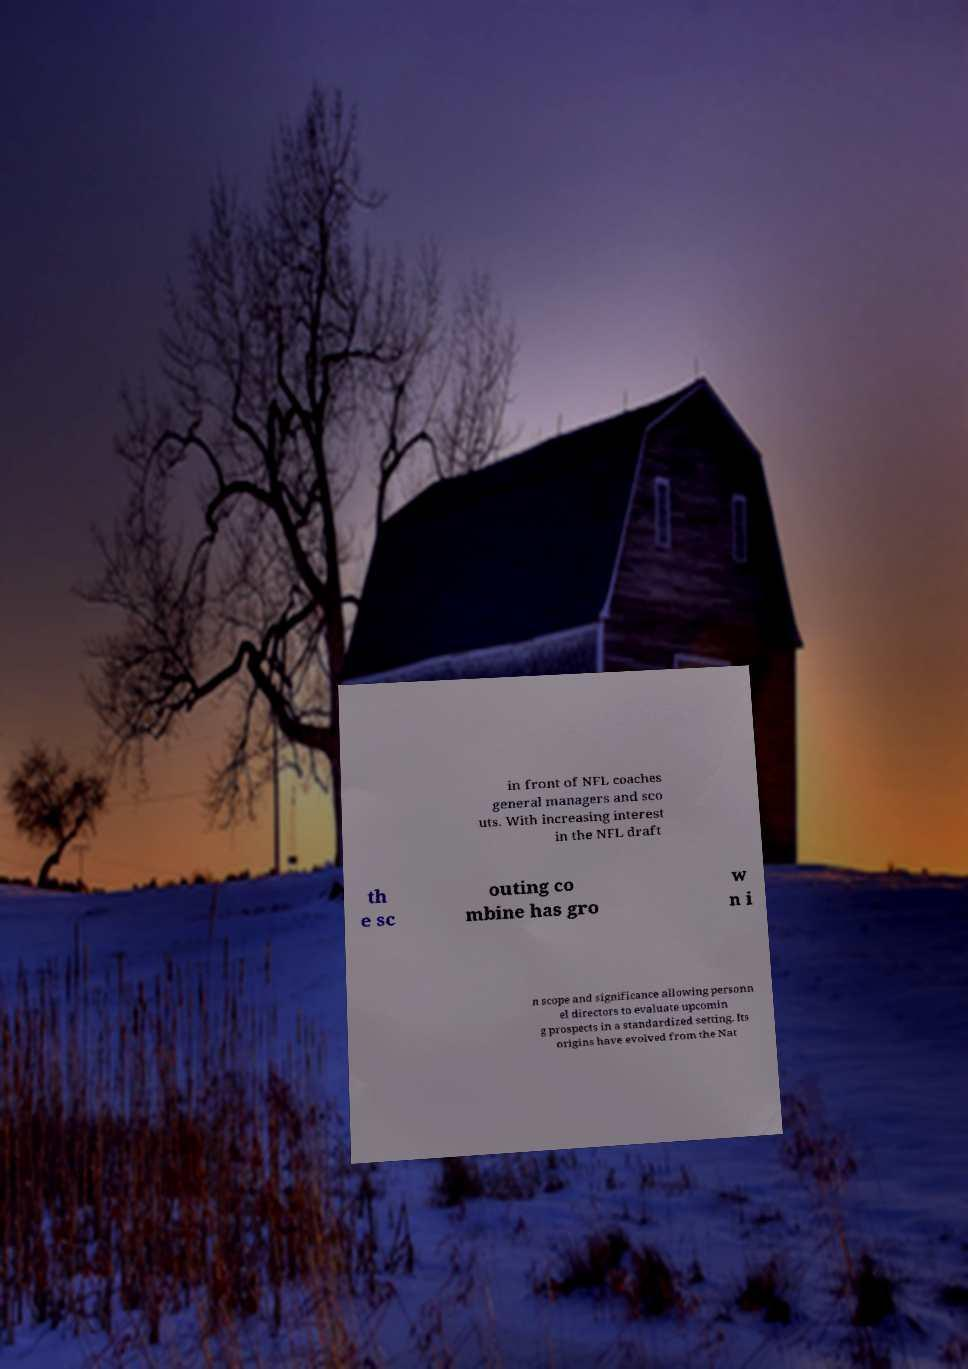There's text embedded in this image that I need extracted. Can you transcribe it verbatim? in front of NFL coaches general managers and sco uts. With increasing interest in the NFL draft th e sc outing co mbine has gro w n i n scope and significance allowing personn el directors to evaluate upcomin g prospects in a standardized setting. Its origins have evolved from the Nat 